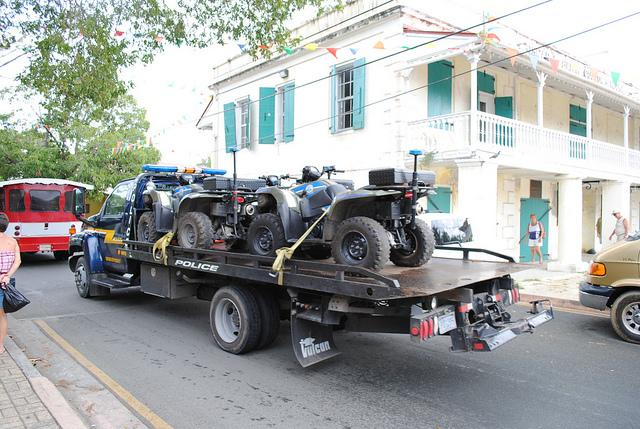The ATVs being carried on the flatbed truck are used by which public agency? Please explain your reasoning. police. The atvs have flashing lights on them and are blue in color. 